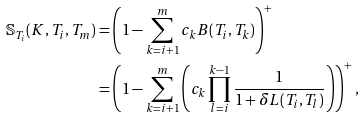Convert formula to latex. <formula><loc_0><loc_0><loc_500><loc_500>\mathbb { S } _ { T _ { i } } ( K , T _ { i } , T _ { m } ) & = \left ( 1 - \sum ^ { m } _ { k = i + 1 } c _ { k } B ( T _ { i } , T _ { k } ) \right ) ^ { + } \\ & = \left ( 1 - \sum ^ { m } _ { k = i + 1 } \left ( c _ { k } \prod _ { l = i } ^ { k - 1 } \frac { 1 } { 1 + \delta L ( T _ { i } , T _ { l } ) } \right ) \right ) ^ { + } ,</formula> 